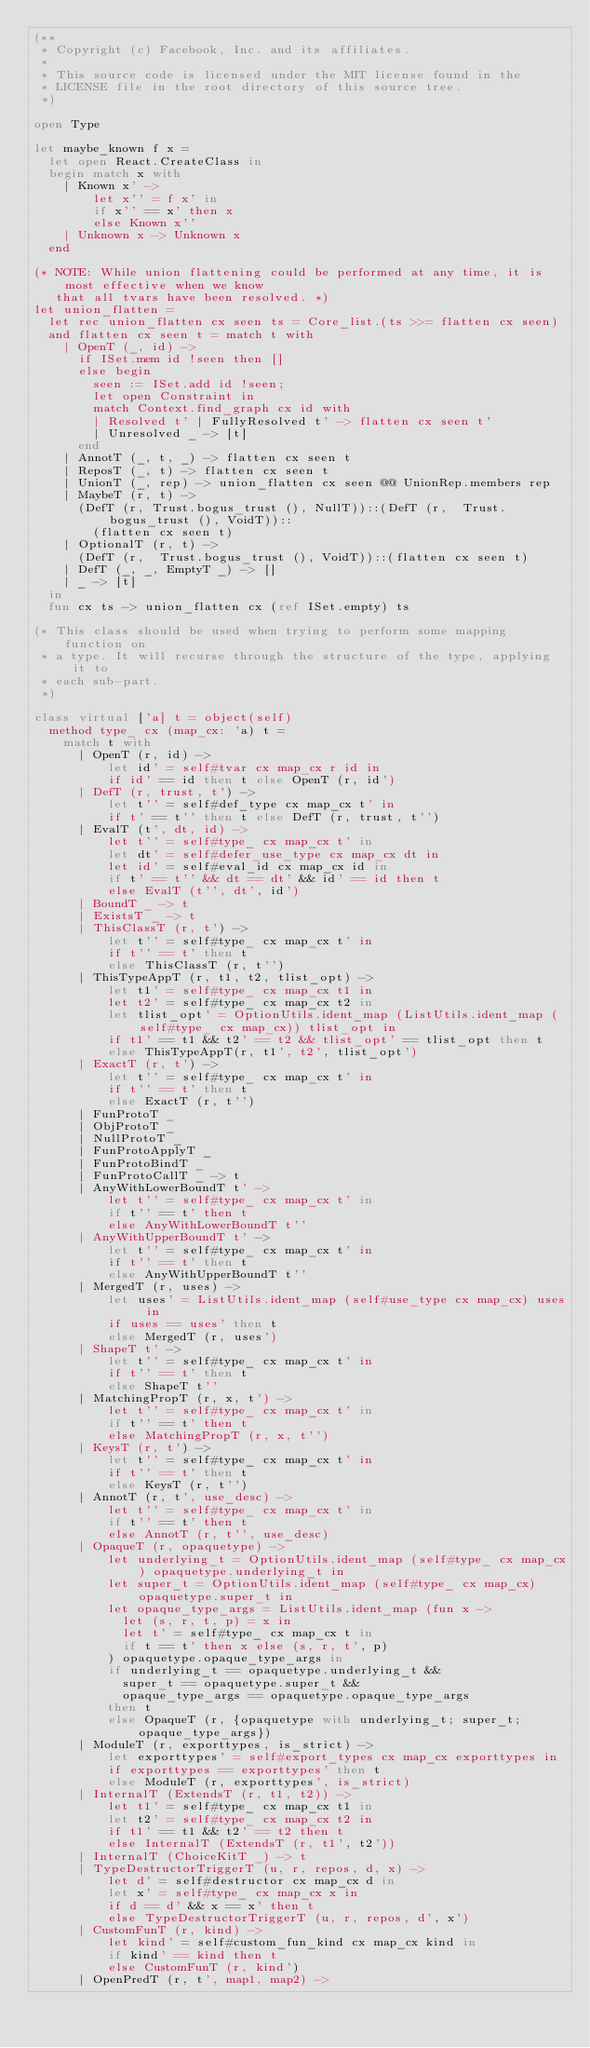Convert code to text. <code><loc_0><loc_0><loc_500><loc_500><_OCaml_>(**
 * Copyright (c) Facebook, Inc. and its affiliates.
 *
 * This source code is licensed under the MIT license found in the
 * LICENSE file in the root directory of this source tree.
 *)

open Type

let maybe_known f x =
  let open React.CreateClass in
  begin match x with
    | Known x' ->
        let x'' = f x' in
        if x'' == x' then x
        else Known x''
    | Unknown x -> Unknown x
  end

(* NOTE: While union flattening could be performed at any time, it is most effective when we know
   that all tvars have been resolved. *)
let union_flatten =
  let rec union_flatten cx seen ts = Core_list.(ts >>= flatten cx seen)
  and flatten cx seen t = match t with
    | OpenT (_, id) ->
      if ISet.mem id !seen then []
      else begin
        seen := ISet.add id !seen;
        let open Constraint in
        match Context.find_graph cx id with
        | Resolved t' | FullyResolved t' -> flatten cx seen t'
        | Unresolved _ -> [t]
      end
    | AnnotT (_, t, _) -> flatten cx seen t
    | ReposT (_, t) -> flatten cx seen t
    | UnionT (_, rep) -> union_flatten cx seen @@ UnionRep.members rep
    | MaybeT (r, t) ->
      (DefT (r, Trust.bogus_trust (), NullT))::(DefT (r,  Trust.bogus_trust (), VoidT))::
        (flatten cx seen t)
    | OptionalT (r, t) ->
      (DefT (r,  Trust.bogus_trust (), VoidT))::(flatten cx seen t)
    | DefT (_, _, EmptyT _) -> []
    | _ -> [t]
  in
  fun cx ts -> union_flatten cx (ref ISet.empty) ts

(* This class should be used when trying to perform some mapping function on
 * a type. It will recurse through the structure of the type, applying it to
 * each sub-part.
 *)

class virtual ['a] t = object(self)
  method type_ cx (map_cx: 'a) t =
    match t with
      | OpenT (r, id) ->
          let id' = self#tvar cx map_cx r id in
          if id' == id then t else OpenT (r, id')
      | DefT (r, trust, t') ->
          let t'' = self#def_type cx map_cx t' in
          if t' == t'' then t else DefT (r, trust, t'')
      | EvalT (t', dt, id) ->
          let t'' = self#type_ cx map_cx t' in
          let dt' = self#defer_use_type cx map_cx dt in
          let id' = self#eval_id cx map_cx id in
          if t' == t'' && dt == dt' && id' == id then t
          else EvalT (t'', dt', id')
      | BoundT _ -> t
      | ExistsT _ -> t
      | ThisClassT (r, t') ->
          let t'' = self#type_ cx map_cx t' in
          if t'' == t' then t
          else ThisClassT (r, t'')
      | ThisTypeAppT (r, t1, t2, tlist_opt) ->
          let t1' = self#type_ cx map_cx t1 in
          let t2' = self#type_ cx map_cx t2 in
          let tlist_opt' = OptionUtils.ident_map (ListUtils.ident_map (self#type_ cx map_cx)) tlist_opt in
          if t1' == t1 && t2' == t2 && tlist_opt' == tlist_opt then t
          else ThisTypeAppT(r, t1', t2', tlist_opt')
      | ExactT (r, t') ->
          let t'' = self#type_ cx map_cx t' in
          if t'' == t' then t
          else ExactT (r, t'')
      | FunProtoT _
      | ObjProtoT _
      | NullProtoT _
      | FunProtoApplyT _
      | FunProtoBindT _
      | FunProtoCallT _ -> t
      | AnyWithLowerBoundT t' ->
          let t'' = self#type_ cx map_cx t' in
          if t'' == t' then t
          else AnyWithLowerBoundT t''
      | AnyWithUpperBoundT t' ->
          let t'' = self#type_ cx map_cx t' in
          if t'' == t' then t
          else AnyWithUpperBoundT t''
      | MergedT (r, uses) ->
          let uses' = ListUtils.ident_map (self#use_type cx map_cx) uses in
          if uses == uses' then t
          else MergedT (r, uses')
      | ShapeT t' ->
          let t'' = self#type_ cx map_cx t' in
          if t'' == t' then t
          else ShapeT t''
      | MatchingPropT (r, x, t') ->
          let t'' = self#type_ cx map_cx t' in
          if t'' == t' then t
          else MatchingPropT (r, x, t'')
      | KeysT (r, t') ->
          let t'' = self#type_ cx map_cx t' in
          if t'' == t' then t
          else KeysT (r, t'')
      | AnnotT (r, t', use_desc) ->
          let t'' = self#type_ cx map_cx t' in
          if t'' == t' then t
          else AnnotT (r, t'', use_desc)
      | OpaqueT (r, opaquetype) ->
          let underlying_t = OptionUtils.ident_map (self#type_ cx map_cx) opaquetype.underlying_t in
          let super_t = OptionUtils.ident_map (self#type_ cx map_cx) opaquetype.super_t in
          let opaque_type_args = ListUtils.ident_map (fun x ->
            let (s, r, t, p) = x in
            let t' = self#type_ cx map_cx t in
            if t == t' then x else (s, r, t', p)
          ) opaquetype.opaque_type_args in
          if underlying_t == opaquetype.underlying_t &&
            super_t == opaquetype.super_t &&
            opaque_type_args == opaquetype.opaque_type_args
          then t
          else OpaqueT (r, {opaquetype with underlying_t; super_t; opaque_type_args})
      | ModuleT (r, exporttypes, is_strict) ->
          let exporttypes' = self#export_types cx map_cx exporttypes in
          if exporttypes == exporttypes' then t
          else ModuleT (r, exporttypes', is_strict)
      | InternalT (ExtendsT (r, t1, t2)) ->
          let t1' = self#type_ cx map_cx t1 in
          let t2' = self#type_ cx map_cx t2 in
          if t1' == t1 && t2' == t2 then t
          else InternalT (ExtendsT (r, t1', t2'))
      | InternalT (ChoiceKitT _) -> t
      | TypeDestructorTriggerT (u, r, repos, d, x) ->
          let d' = self#destructor cx map_cx d in
          let x' = self#type_ cx map_cx x in
          if d == d' && x == x' then t
          else TypeDestructorTriggerT (u, r, repos, d', x')
      | CustomFunT (r, kind) ->
          let kind' = self#custom_fun_kind cx map_cx kind in
          if kind' == kind then t
          else CustomFunT (r, kind')
      | OpenPredT (r, t', map1, map2) -></code> 